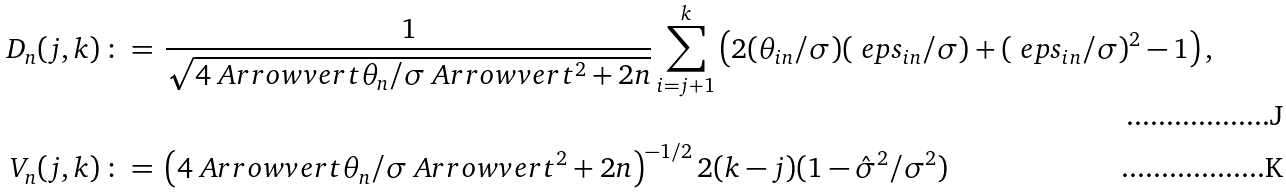<formula> <loc_0><loc_0><loc_500><loc_500>D _ { n } ( j , k ) \, & \colon = \, \frac { 1 } { \sqrt { 4 \ A r r o w v e r t \theta _ { n } / \sigma \ A r r o w v e r t ^ { 2 } + 2 n } } \sum _ { i = j + 1 } ^ { k } \left ( 2 ( \theta _ { i n } / \sigma ) ( \ e p s _ { i n } / \sigma ) + ( \ e p s _ { i n } / \sigma ) ^ { 2 } - 1 \right ) , \\ V _ { n } ( j , k ) \, & \colon = \, \left ( 4 \ A r r o w v e r t \theta _ { n } / \sigma \ A r r o w v e r t ^ { 2 } + 2 n \right ) ^ { - 1 / 2 } 2 ( k - j ) ( 1 - \hat { \sigma } ^ { 2 } / \sigma ^ { 2 } )</formula> 